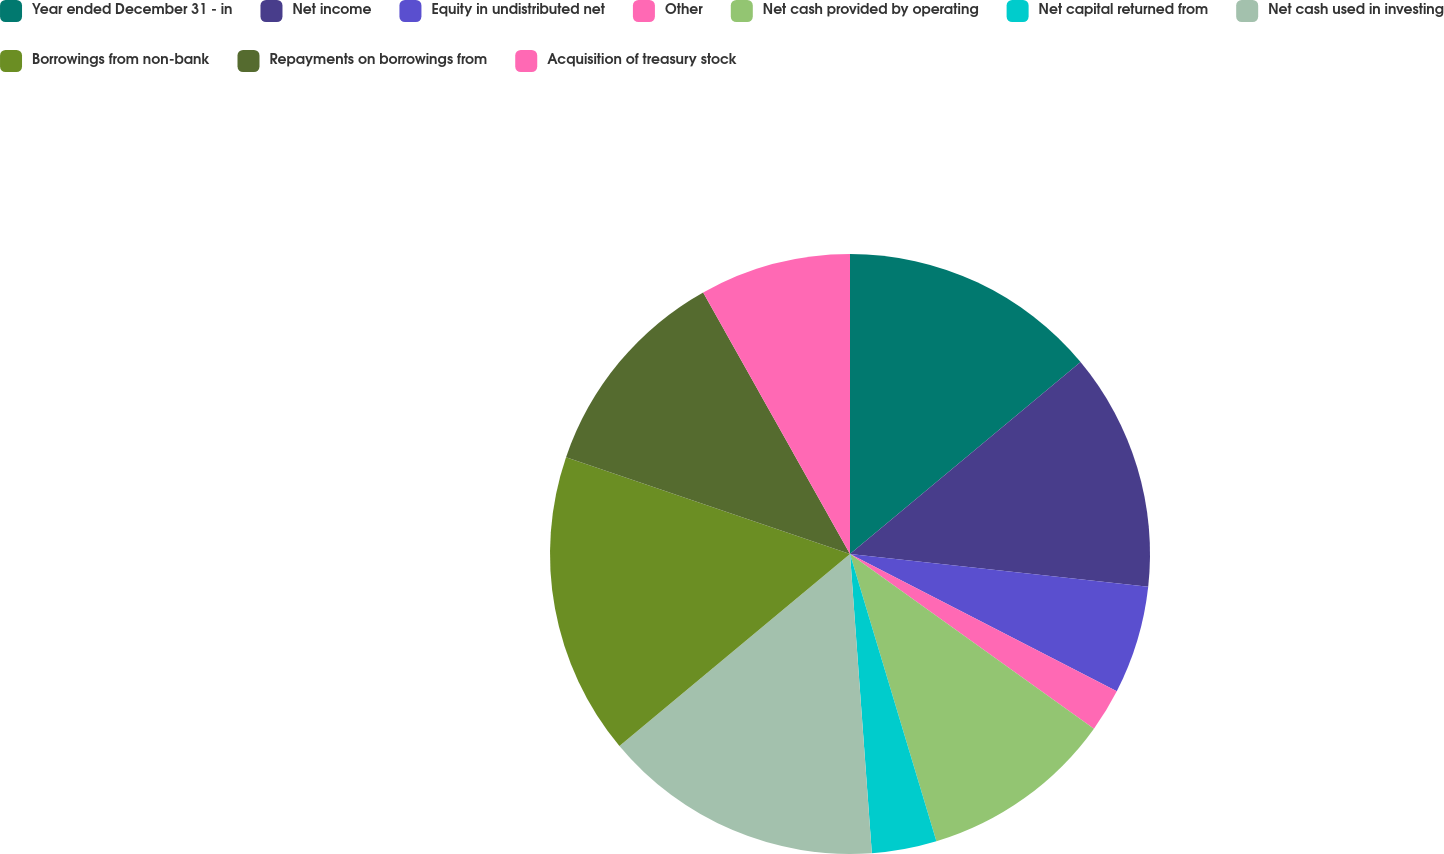<chart> <loc_0><loc_0><loc_500><loc_500><pie_chart><fcel>Year ended December 31 - in<fcel>Net income<fcel>Equity in undistributed net<fcel>Other<fcel>Net cash provided by operating<fcel>Net capital returned from<fcel>Net cash used in investing<fcel>Borrowings from non-bank<fcel>Repayments on borrowings from<fcel>Acquisition of treasury stock<nl><fcel>13.95%<fcel>12.79%<fcel>5.82%<fcel>2.33%<fcel>10.46%<fcel>3.49%<fcel>15.11%<fcel>16.28%<fcel>11.63%<fcel>8.14%<nl></chart> 